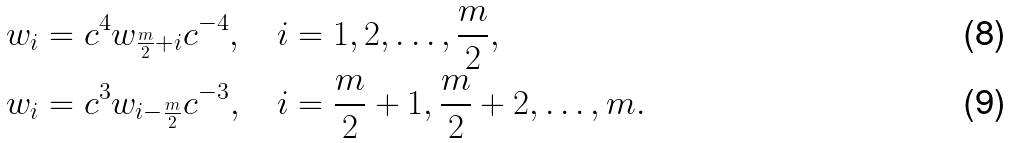<formula> <loc_0><loc_0><loc_500><loc_500>w _ { i } & = c ^ { 4 } w _ { \frac { m } { 2 } + i } c ^ { - 4 } , \quad i = 1 , 2 , \dots , \frac { m } 2 , \\ w _ { i } & = c ^ { 3 } w _ { i - \frac { m } 2 } c ^ { - 3 } , \quad i = \frac { m } 2 + 1 , \frac { m } 2 + 2 , \dots , m .</formula> 